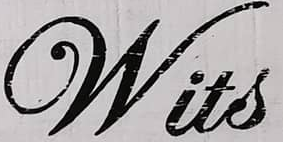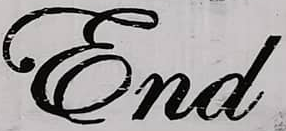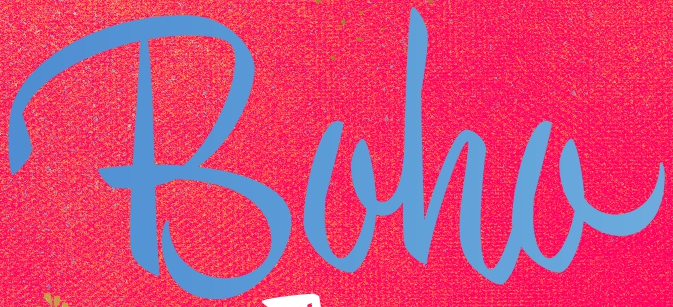What words can you see in these images in sequence, separated by a semicolon? Wits; End; Boha 